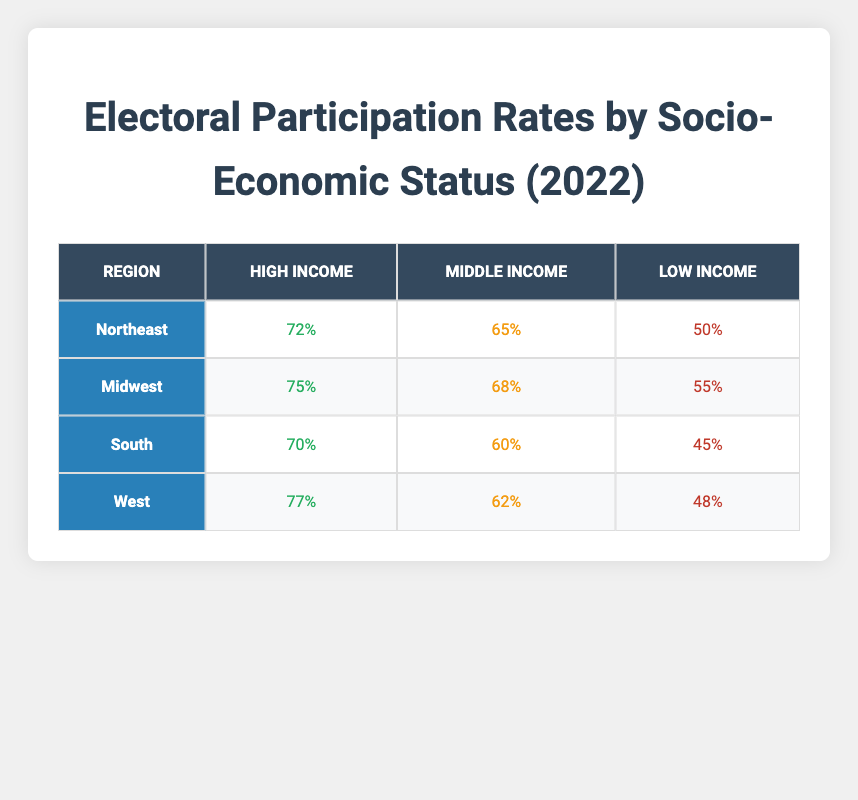What is the electoral participation rate for high-income individuals in the Midwest? The table lists the electoral participation rates by socio-economic status for different regions. Under the Midwest region, the participation rate for high-income individuals is indicated as 75%.
Answer: 75% What is the lowest electoral participation rate among low-income individuals across all regions? To find the lowest rate, we compare the low-income rates across all regions: Northeast (50%), Midwest (55%), South (45%), and West (48%). The lowest rate is 45% in the South.
Answer: 45% Which region has the highest electoral participation rate for middle-income individuals? The middle-income electoral participation rates are as follows: Northeast (65%), Midwest (68%), South (60%), and West (62%). The highest rate is recorded in the Midwest at 68%.
Answer: Midwest What is the average electoral participation rate for high-income people across all regions? The high-income participation rates are: Northeast (72%), Midwest (75%), South (70%), and West (77%). We sum these values: 72 + 75 + 70 + 77 = 294. Dividing by the number of regions (4) gives us an average of 294 / 4 = 73.5%.
Answer: 73.5% Is it true that low-income individuals have a higher participation rate in the Midwest compared to those in the South? We check the rates: in the Midwest, low-income individuals participate at 55%, while in the South, they participate at 45%. Therefore, it is true that the Midwest's low-income rate is higher.
Answer: Yes What is the difference in electoral participation rates between high-income and low-income individuals in the Northeast? For the Northeast, high-income participation is 72% and low-income participation is 50%. The difference is calculated by subtracting the low-income rate from the high-income rate: 72% - 50% = 22%.
Answer: 22% Which region has a participation rate for middle-income individuals that is lower than the average rate across all regions? The average middle-income rate is calculated as (65% + 68% + 60% + 62%) / 4 = 63.75%. The South has a middle-income rate of 60%, which is lower than 63.75%.
Answer: South If the electoral participation rates for high-income individuals in the West and Midwest are combined, what is the total? The high-income rates are 77% for the West and 75% for the Midwest. Adding these two rates together gives us: 77% + 75% = 152%.
Answer: 152% 